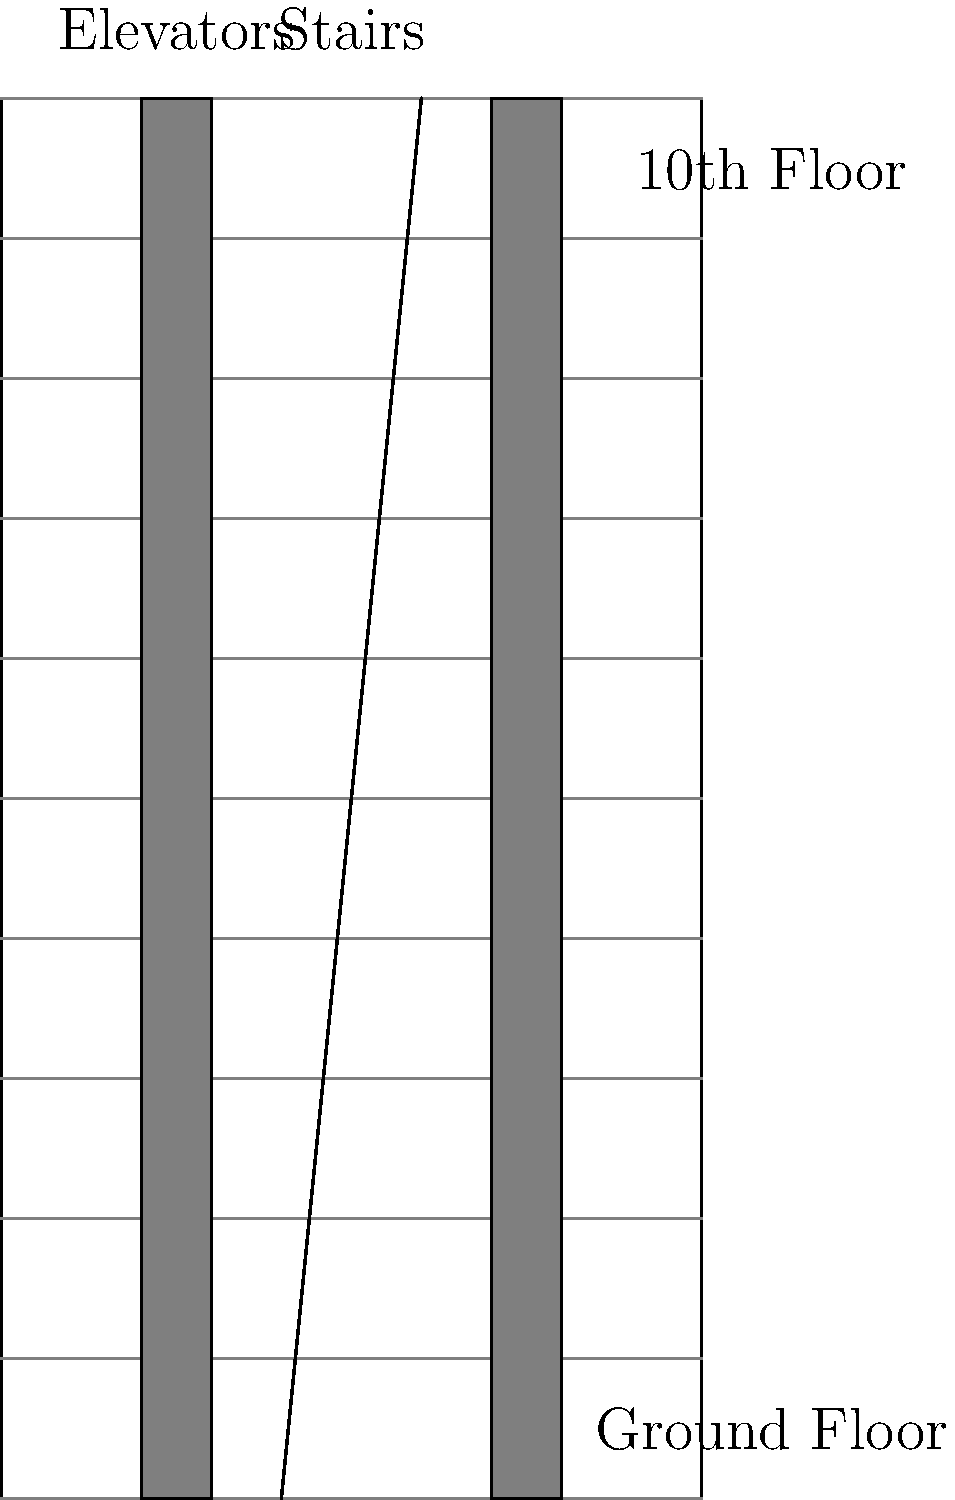Based on the architectural blueprint of a new high-rise development in Lagos, what is the maximum number of floors that can be served by the elevators without requiring a transfer? To determine the maximum number of floors served by the elevators without requiring a transfer, we need to analyze the blueprint:

1. First, observe that the building has vertical lines representing elevator shafts that run continuously from the bottom to the top of the structure.

2. Count the number of horizontal lines representing floors:
   - There are 11 horizontal lines, including the ground floor.
   - The topmost line represents the roof of the 10th floor.

3. Notice that the elevator shafts extend from the ground floor to the top floor without any breaks or transfers.

4. In high-rise buildings, elevators typically serve all floors they pass through unless there's a specific design for express elevators or transfer floors, which is not indicated in this blueprint.

5. Therefore, the elevators can serve all floors from the ground floor to the 10th floor without requiring a transfer.

6. To calculate the total number of floors served:
   $\text{Total floors} = \text{Top floor number} + 1$ (to include the ground floor)
   $\text{Total floors} = 10 + 1 = 11$

Thus, the elevators can serve a maximum of 11 floors without requiring a transfer.
Answer: 11 floors 